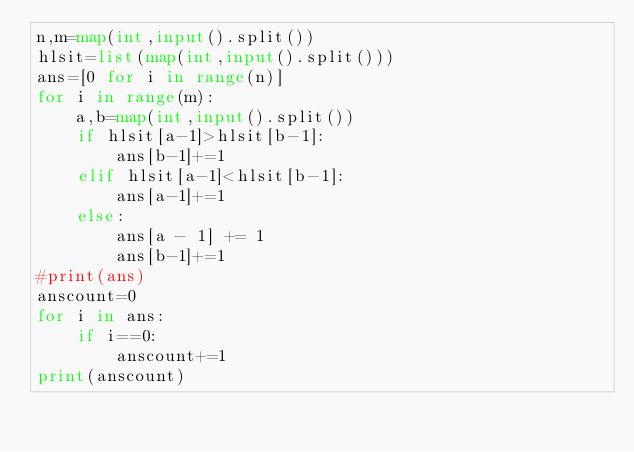<code> <loc_0><loc_0><loc_500><loc_500><_Python_>n,m=map(int,input().split())
hlsit=list(map(int,input().split()))
ans=[0 for i in range(n)]
for i in range(m):
    a,b=map(int,input().split())
    if hlsit[a-1]>hlsit[b-1]:
        ans[b-1]+=1
    elif hlsit[a-1]<hlsit[b-1]:
        ans[a-1]+=1
    else:
        ans[a - 1] += 1
        ans[b-1]+=1
#print(ans)
anscount=0
for i in ans:
    if i==0:
        anscount+=1
print(anscount)</code> 